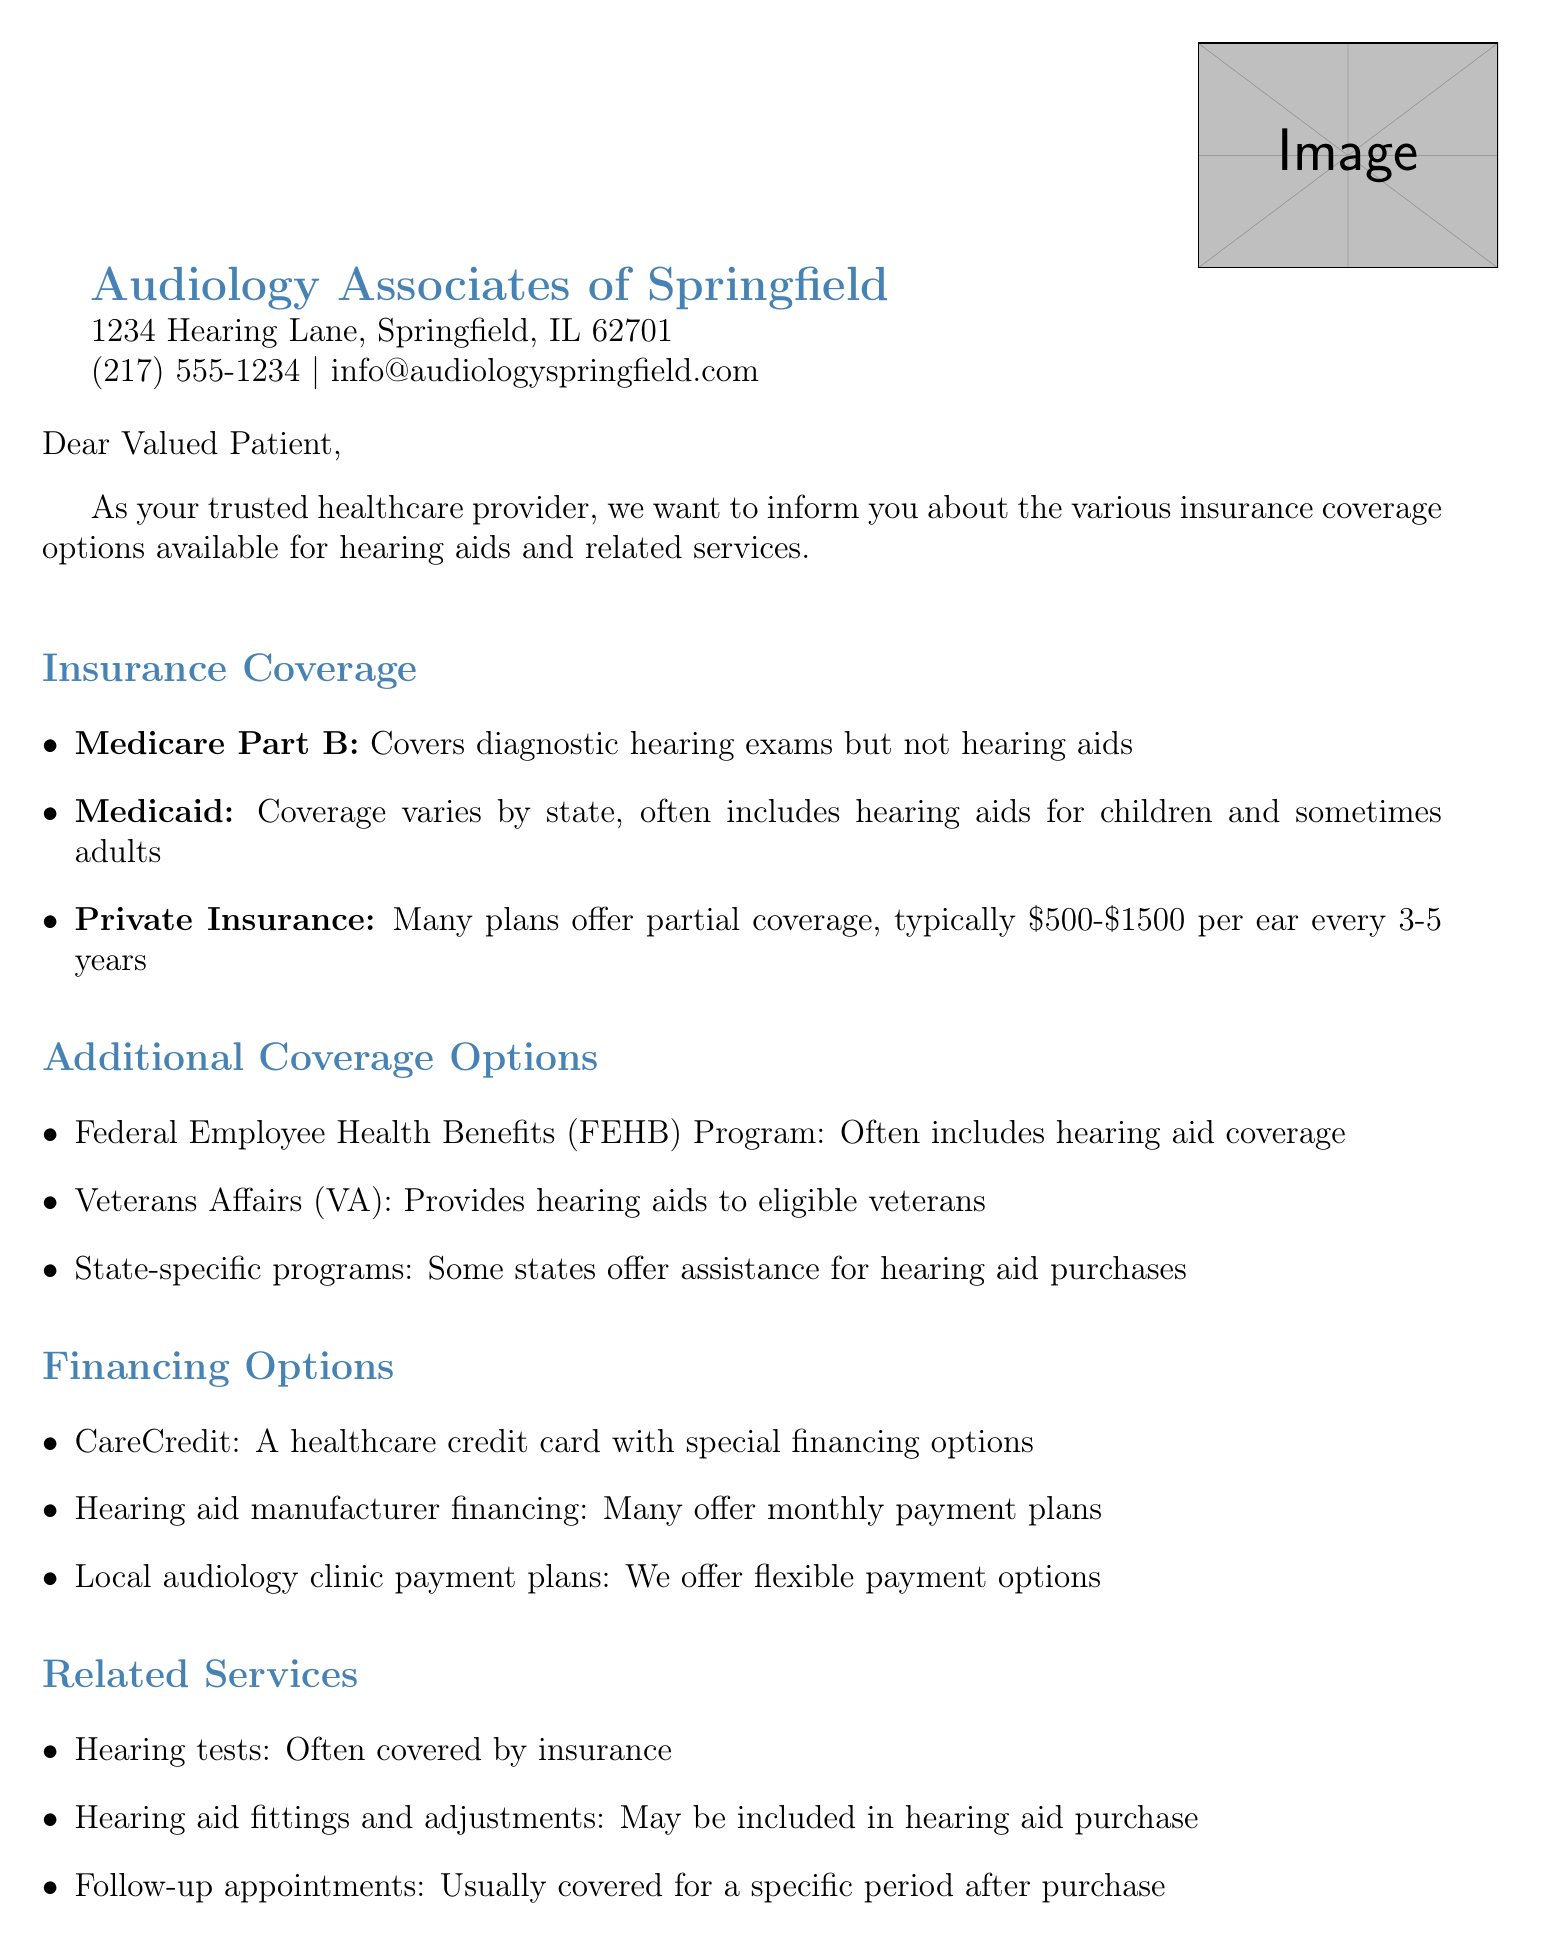What is the name of the healthcare provider? The healthcare provider's name is listed at the top of the document.
Answer: Audiology Associates of Springfield What is the phone number of the provider? The document provides a contact phone number for the healthcare provider.
Answer: (217) 555-1234 Which insurance covers diagnostic hearing exams? The document states which insurance covers specific services, including hearing exams.
Answer: Medicare Part B What financing option is mentioned for hearing aids? The document lists various financing options available for hearing aids specifically.
Answer: CareCredit What type of assistance do state-specific programs offer? The document provides information about additional coverage options available through certain state programs.
Answer: Assistance for hearing aid purchases How long is the typical coverage period for private insurance? The document mentions a typical coverage timeline for private insurance relating to hearing aids.
Answer: Every 3-5 years Who signed the letter? The document concludes with a signature, providing the name of the person who signed the letter.
Answer: Dr. Emily Johnson, Au.D What related service is often covered by insurance? The document lists services that may be covered, including hearing tests.
Answer: Hearing tests Does Medicaid cover hearing aids for adults? The document indicates that Medicaid coverage may vary by state regarding adult coverage.
Answer: Sometimes 